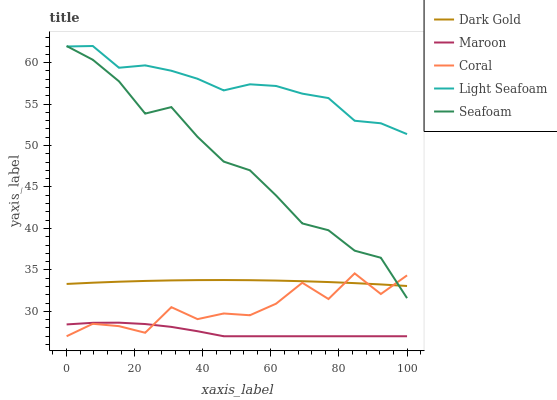Does Maroon have the minimum area under the curve?
Answer yes or no. Yes. Does Light Seafoam have the maximum area under the curve?
Answer yes or no. Yes. Does Seafoam have the minimum area under the curve?
Answer yes or no. No. Does Seafoam have the maximum area under the curve?
Answer yes or no. No. Is Dark Gold the smoothest?
Answer yes or no. Yes. Is Coral the roughest?
Answer yes or no. Yes. Is Light Seafoam the smoothest?
Answer yes or no. No. Is Light Seafoam the roughest?
Answer yes or no. No. Does Coral have the lowest value?
Answer yes or no. Yes. Does Seafoam have the lowest value?
Answer yes or no. No. Does Seafoam have the highest value?
Answer yes or no. Yes. Does Maroon have the highest value?
Answer yes or no. No. Is Maroon less than Light Seafoam?
Answer yes or no. Yes. Is Seafoam greater than Maroon?
Answer yes or no. Yes. Does Seafoam intersect Light Seafoam?
Answer yes or no. Yes. Is Seafoam less than Light Seafoam?
Answer yes or no. No. Is Seafoam greater than Light Seafoam?
Answer yes or no. No. Does Maroon intersect Light Seafoam?
Answer yes or no. No. 